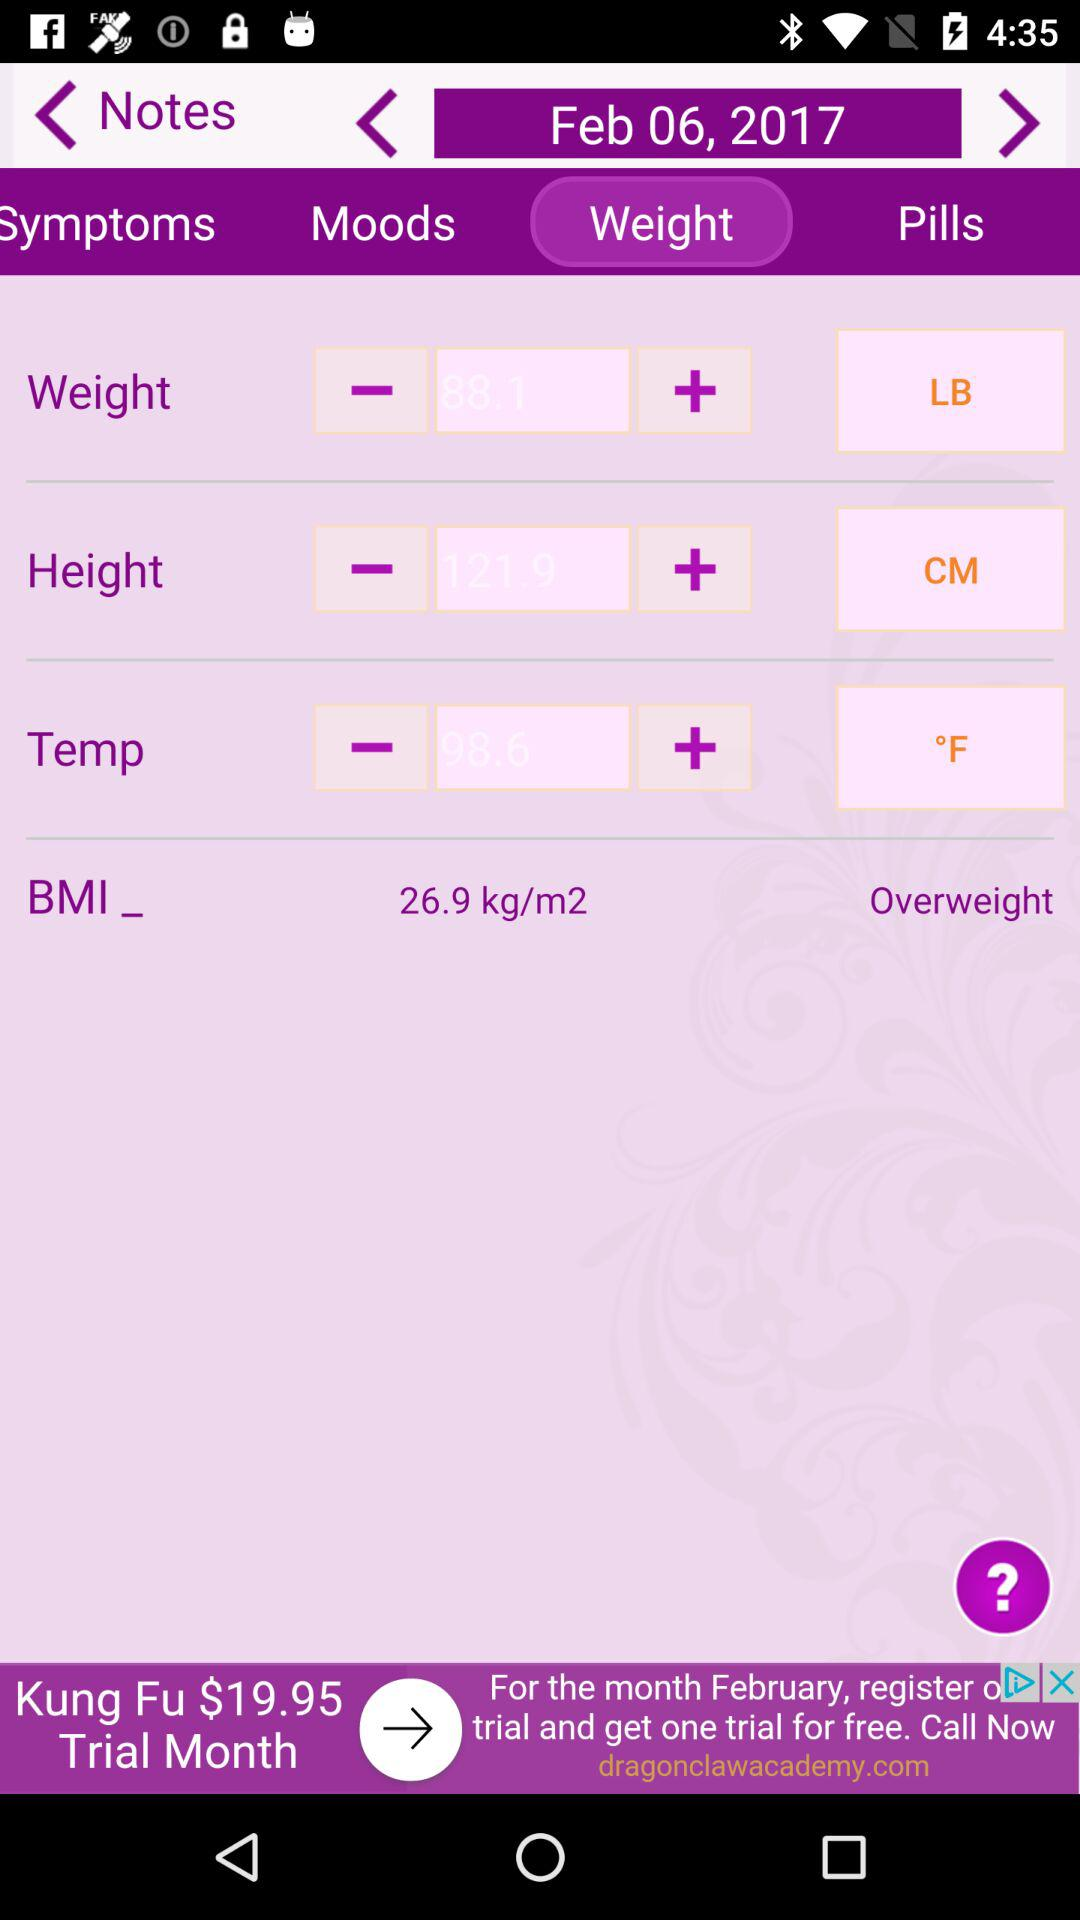What is the weight?
When the provided information is insufficient, respond with <no answer>. <no answer> 